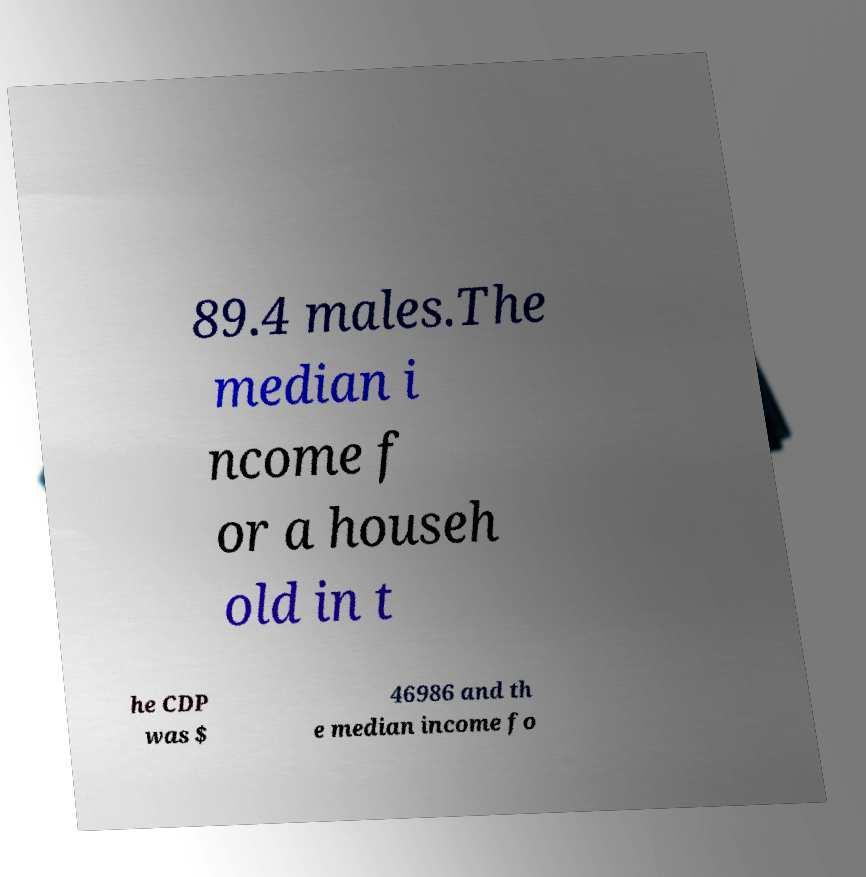What messages or text are displayed in this image? I need them in a readable, typed format. 89.4 males.The median i ncome f or a househ old in t he CDP was $ 46986 and th e median income fo 